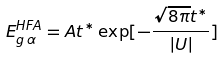Convert formula to latex. <formula><loc_0><loc_0><loc_500><loc_500>E _ { g \, \alpha } ^ { H F A } = A t ^ { * } \exp [ - \frac { \sqrt { 8 \pi } t ^ { * } } { | U | } ]</formula> 